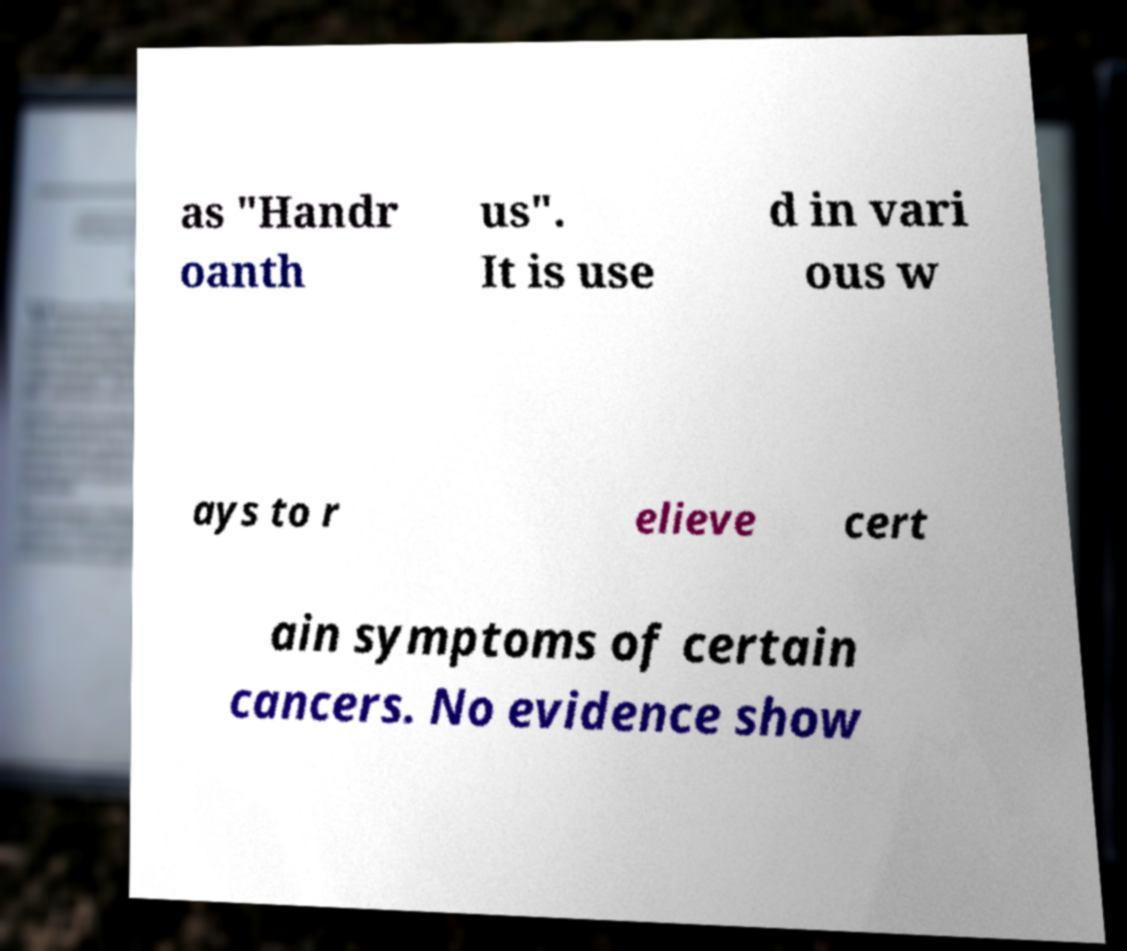For documentation purposes, I need the text within this image transcribed. Could you provide that? as "Handr oanth us". It is use d in vari ous w ays to r elieve cert ain symptoms of certain cancers. No evidence show 